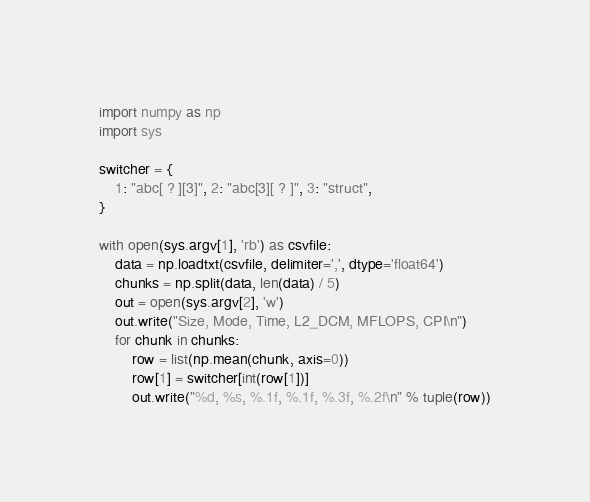<code> <loc_0><loc_0><loc_500><loc_500><_Python_>import numpy as np
import sys

switcher = {
    1: "abc[ ? ][3]", 2: "abc[3][ ? ]", 3: "struct",
}

with open(sys.argv[1], 'rb') as csvfile:
    data = np.loadtxt(csvfile, delimiter=',', dtype='float64')
    chunks = np.split(data, len(data) / 5)
    out = open(sys.argv[2], 'w')
    out.write("Size, Mode, Time, L2_DCM, MFLOPS, CPI\n")
    for chunk in chunks:
        row = list(np.mean(chunk, axis=0))
        row[1] = switcher[int(row[1])]
        out.write("%d, %s, %.1f, %.1f, %.3f, %.2f\n" % tuple(row))
</code> 